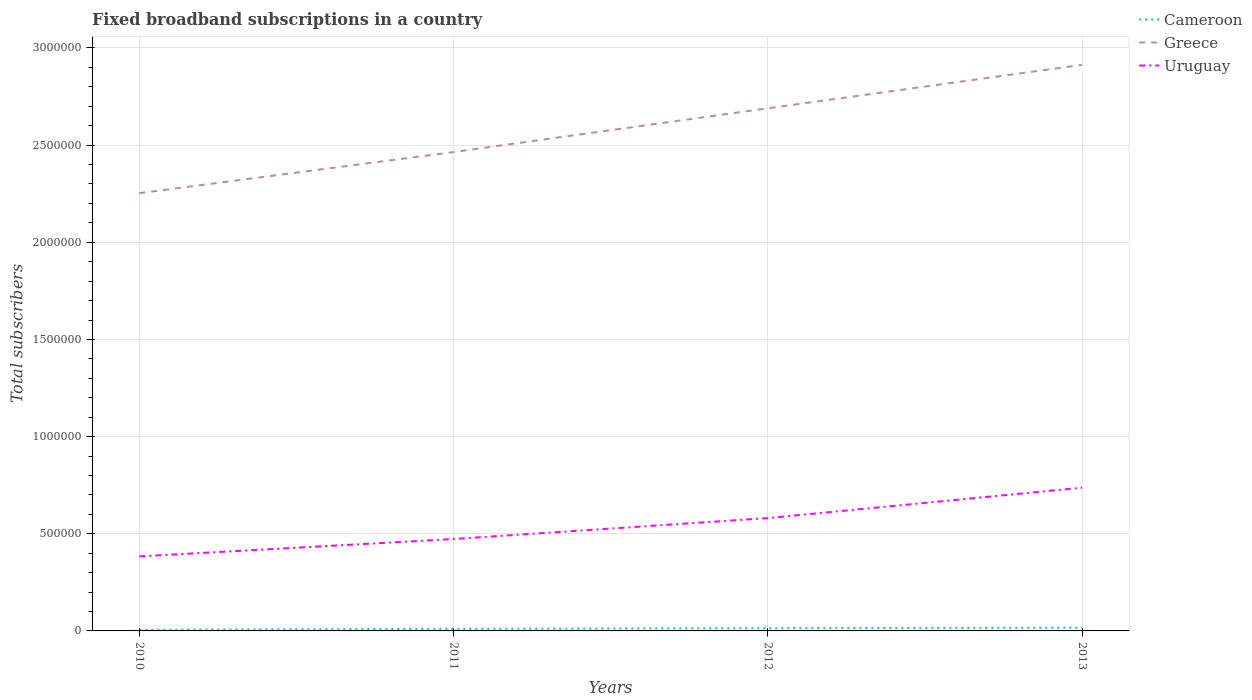Does the line corresponding to Greece intersect with the line corresponding to Uruguay?
Your response must be concise. No. Is the number of lines equal to the number of legend labels?
Provide a succinct answer. Yes. Across all years, what is the maximum number of broadband subscriptions in Uruguay?
Provide a short and direct response. 3.84e+05. In which year was the number of broadband subscriptions in Greece maximum?
Your answer should be very brief. 2010. What is the total number of broadband subscriptions in Greece in the graph?
Offer a very short reply. -2.12e+05. What is the difference between the highest and the second highest number of broadband subscriptions in Greece?
Your answer should be compact. 6.61e+05. What is the difference between the highest and the lowest number of broadband subscriptions in Greece?
Your response must be concise. 2. Is the number of broadband subscriptions in Greece strictly greater than the number of broadband subscriptions in Uruguay over the years?
Your answer should be very brief. No. What is the difference between two consecutive major ticks on the Y-axis?
Your response must be concise. 5.00e+05. Does the graph contain any zero values?
Ensure brevity in your answer.  No. Where does the legend appear in the graph?
Your response must be concise. Top right. How many legend labels are there?
Make the answer very short. 3. How are the legend labels stacked?
Offer a very short reply. Vertical. What is the title of the graph?
Make the answer very short. Fixed broadband subscriptions in a country. What is the label or title of the X-axis?
Keep it short and to the point. Years. What is the label or title of the Y-axis?
Your response must be concise. Total subscribers. What is the Total subscribers in Cameroon in 2010?
Offer a terse response. 5954. What is the Total subscribers of Greece in 2010?
Provide a succinct answer. 2.25e+06. What is the Total subscribers of Uruguay in 2010?
Provide a succinct answer. 3.84e+05. What is the Total subscribers of Cameroon in 2011?
Provide a succinct answer. 1.07e+04. What is the Total subscribers in Greece in 2011?
Ensure brevity in your answer.  2.46e+06. What is the Total subscribers in Uruguay in 2011?
Give a very brief answer. 4.73e+05. What is the Total subscribers in Cameroon in 2012?
Provide a short and direct response. 1.38e+04. What is the Total subscribers in Greece in 2012?
Your answer should be very brief. 2.69e+06. What is the Total subscribers in Uruguay in 2012?
Provide a short and direct response. 5.81e+05. What is the Total subscribers in Cameroon in 2013?
Keep it short and to the point. 1.69e+04. What is the Total subscribers of Greece in 2013?
Provide a succinct answer. 2.91e+06. What is the Total subscribers in Uruguay in 2013?
Provide a succinct answer. 7.37e+05. Across all years, what is the maximum Total subscribers of Cameroon?
Make the answer very short. 1.69e+04. Across all years, what is the maximum Total subscribers of Greece?
Keep it short and to the point. 2.91e+06. Across all years, what is the maximum Total subscribers of Uruguay?
Ensure brevity in your answer.  7.37e+05. Across all years, what is the minimum Total subscribers in Cameroon?
Make the answer very short. 5954. Across all years, what is the minimum Total subscribers in Greece?
Your answer should be compact. 2.25e+06. Across all years, what is the minimum Total subscribers in Uruguay?
Keep it short and to the point. 3.84e+05. What is the total Total subscribers in Cameroon in the graph?
Your answer should be very brief. 4.74e+04. What is the total Total subscribers of Greece in the graph?
Your response must be concise. 1.03e+07. What is the total Total subscribers in Uruguay in the graph?
Your answer should be compact. 2.17e+06. What is the difference between the Total subscribers in Cameroon in 2010 and that in 2011?
Provide a succinct answer. -4759. What is the difference between the Total subscribers in Greece in 2010 and that in 2011?
Offer a terse response. -2.12e+05. What is the difference between the Total subscribers in Uruguay in 2010 and that in 2011?
Your answer should be compact. -8.93e+04. What is the difference between the Total subscribers of Cameroon in 2010 and that in 2012?
Your response must be concise. -7892. What is the difference between the Total subscribers in Greece in 2010 and that in 2012?
Give a very brief answer. -4.37e+05. What is the difference between the Total subscribers in Uruguay in 2010 and that in 2012?
Your response must be concise. -1.97e+05. What is the difference between the Total subscribers in Cameroon in 2010 and that in 2013?
Offer a terse response. -1.09e+04. What is the difference between the Total subscribers of Greece in 2010 and that in 2013?
Provide a succinct answer. -6.61e+05. What is the difference between the Total subscribers in Uruguay in 2010 and that in 2013?
Give a very brief answer. -3.54e+05. What is the difference between the Total subscribers in Cameroon in 2011 and that in 2012?
Make the answer very short. -3133. What is the difference between the Total subscribers of Greece in 2011 and that in 2012?
Ensure brevity in your answer.  -2.25e+05. What is the difference between the Total subscribers of Uruguay in 2011 and that in 2012?
Ensure brevity in your answer.  -1.08e+05. What is the difference between the Total subscribers of Cameroon in 2011 and that in 2013?
Give a very brief answer. -6187. What is the difference between the Total subscribers of Greece in 2011 and that in 2013?
Give a very brief answer. -4.49e+05. What is the difference between the Total subscribers of Uruguay in 2011 and that in 2013?
Provide a short and direct response. -2.64e+05. What is the difference between the Total subscribers of Cameroon in 2012 and that in 2013?
Offer a very short reply. -3054. What is the difference between the Total subscribers in Greece in 2012 and that in 2013?
Give a very brief answer. -2.24e+05. What is the difference between the Total subscribers in Uruguay in 2012 and that in 2013?
Offer a terse response. -1.56e+05. What is the difference between the Total subscribers of Cameroon in 2010 and the Total subscribers of Greece in 2011?
Ensure brevity in your answer.  -2.46e+06. What is the difference between the Total subscribers in Cameroon in 2010 and the Total subscribers in Uruguay in 2011?
Offer a terse response. -4.67e+05. What is the difference between the Total subscribers of Greece in 2010 and the Total subscribers of Uruguay in 2011?
Keep it short and to the point. 1.78e+06. What is the difference between the Total subscribers in Cameroon in 2010 and the Total subscribers in Greece in 2012?
Ensure brevity in your answer.  -2.68e+06. What is the difference between the Total subscribers of Cameroon in 2010 and the Total subscribers of Uruguay in 2012?
Ensure brevity in your answer.  -5.75e+05. What is the difference between the Total subscribers in Greece in 2010 and the Total subscribers in Uruguay in 2012?
Ensure brevity in your answer.  1.67e+06. What is the difference between the Total subscribers in Cameroon in 2010 and the Total subscribers in Greece in 2013?
Give a very brief answer. -2.91e+06. What is the difference between the Total subscribers of Cameroon in 2010 and the Total subscribers of Uruguay in 2013?
Keep it short and to the point. -7.31e+05. What is the difference between the Total subscribers of Greece in 2010 and the Total subscribers of Uruguay in 2013?
Provide a short and direct response. 1.52e+06. What is the difference between the Total subscribers of Cameroon in 2011 and the Total subscribers of Greece in 2012?
Keep it short and to the point. -2.68e+06. What is the difference between the Total subscribers of Cameroon in 2011 and the Total subscribers of Uruguay in 2012?
Provide a short and direct response. -5.70e+05. What is the difference between the Total subscribers in Greece in 2011 and the Total subscribers in Uruguay in 2012?
Your answer should be very brief. 1.88e+06. What is the difference between the Total subscribers of Cameroon in 2011 and the Total subscribers of Greece in 2013?
Ensure brevity in your answer.  -2.90e+06. What is the difference between the Total subscribers in Cameroon in 2011 and the Total subscribers in Uruguay in 2013?
Your answer should be very brief. -7.26e+05. What is the difference between the Total subscribers in Greece in 2011 and the Total subscribers in Uruguay in 2013?
Offer a very short reply. 1.73e+06. What is the difference between the Total subscribers in Cameroon in 2012 and the Total subscribers in Greece in 2013?
Your answer should be compact. -2.90e+06. What is the difference between the Total subscribers of Cameroon in 2012 and the Total subscribers of Uruguay in 2013?
Your response must be concise. -7.23e+05. What is the difference between the Total subscribers of Greece in 2012 and the Total subscribers of Uruguay in 2013?
Offer a very short reply. 1.95e+06. What is the average Total subscribers in Cameroon per year?
Ensure brevity in your answer.  1.19e+04. What is the average Total subscribers in Greece per year?
Make the answer very short. 2.58e+06. What is the average Total subscribers in Uruguay per year?
Offer a terse response. 5.44e+05. In the year 2010, what is the difference between the Total subscribers in Cameroon and Total subscribers in Greece?
Keep it short and to the point. -2.25e+06. In the year 2010, what is the difference between the Total subscribers in Cameroon and Total subscribers in Uruguay?
Your answer should be very brief. -3.78e+05. In the year 2010, what is the difference between the Total subscribers of Greece and Total subscribers of Uruguay?
Provide a short and direct response. 1.87e+06. In the year 2011, what is the difference between the Total subscribers in Cameroon and Total subscribers in Greece?
Your response must be concise. -2.45e+06. In the year 2011, what is the difference between the Total subscribers of Cameroon and Total subscribers of Uruguay?
Give a very brief answer. -4.62e+05. In the year 2011, what is the difference between the Total subscribers in Greece and Total subscribers in Uruguay?
Keep it short and to the point. 1.99e+06. In the year 2012, what is the difference between the Total subscribers in Cameroon and Total subscribers in Greece?
Offer a terse response. -2.68e+06. In the year 2012, what is the difference between the Total subscribers in Cameroon and Total subscribers in Uruguay?
Keep it short and to the point. -5.67e+05. In the year 2012, what is the difference between the Total subscribers of Greece and Total subscribers of Uruguay?
Keep it short and to the point. 2.11e+06. In the year 2013, what is the difference between the Total subscribers of Cameroon and Total subscribers of Greece?
Your answer should be very brief. -2.90e+06. In the year 2013, what is the difference between the Total subscribers in Cameroon and Total subscribers in Uruguay?
Your response must be concise. -7.20e+05. In the year 2013, what is the difference between the Total subscribers in Greece and Total subscribers in Uruguay?
Offer a terse response. 2.18e+06. What is the ratio of the Total subscribers of Cameroon in 2010 to that in 2011?
Provide a succinct answer. 0.56. What is the ratio of the Total subscribers of Greece in 2010 to that in 2011?
Offer a terse response. 0.91. What is the ratio of the Total subscribers in Uruguay in 2010 to that in 2011?
Provide a succinct answer. 0.81. What is the ratio of the Total subscribers of Cameroon in 2010 to that in 2012?
Make the answer very short. 0.43. What is the ratio of the Total subscribers of Greece in 2010 to that in 2012?
Your response must be concise. 0.84. What is the ratio of the Total subscribers of Uruguay in 2010 to that in 2012?
Make the answer very short. 0.66. What is the ratio of the Total subscribers of Cameroon in 2010 to that in 2013?
Keep it short and to the point. 0.35. What is the ratio of the Total subscribers of Greece in 2010 to that in 2013?
Offer a very short reply. 0.77. What is the ratio of the Total subscribers in Uruguay in 2010 to that in 2013?
Offer a terse response. 0.52. What is the ratio of the Total subscribers of Cameroon in 2011 to that in 2012?
Your answer should be compact. 0.77. What is the ratio of the Total subscribers of Greece in 2011 to that in 2012?
Provide a succinct answer. 0.92. What is the ratio of the Total subscribers of Uruguay in 2011 to that in 2012?
Offer a terse response. 0.81. What is the ratio of the Total subscribers of Cameroon in 2011 to that in 2013?
Offer a very short reply. 0.63. What is the ratio of the Total subscribers of Greece in 2011 to that in 2013?
Make the answer very short. 0.85. What is the ratio of the Total subscribers of Uruguay in 2011 to that in 2013?
Your response must be concise. 0.64. What is the ratio of the Total subscribers in Cameroon in 2012 to that in 2013?
Offer a very short reply. 0.82. What is the ratio of the Total subscribers in Greece in 2012 to that in 2013?
Provide a succinct answer. 0.92. What is the ratio of the Total subscribers in Uruguay in 2012 to that in 2013?
Give a very brief answer. 0.79. What is the difference between the highest and the second highest Total subscribers of Cameroon?
Offer a very short reply. 3054. What is the difference between the highest and the second highest Total subscribers in Greece?
Your answer should be very brief. 2.24e+05. What is the difference between the highest and the second highest Total subscribers in Uruguay?
Offer a very short reply. 1.56e+05. What is the difference between the highest and the lowest Total subscribers of Cameroon?
Offer a very short reply. 1.09e+04. What is the difference between the highest and the lowest Total subscribers in Greece?
Your response must be concise. 6.61e+05. What is the difference between the highest and the lowest Total subscribers in Uruguay?
Keep it short and to the point. 3.54e+05. 